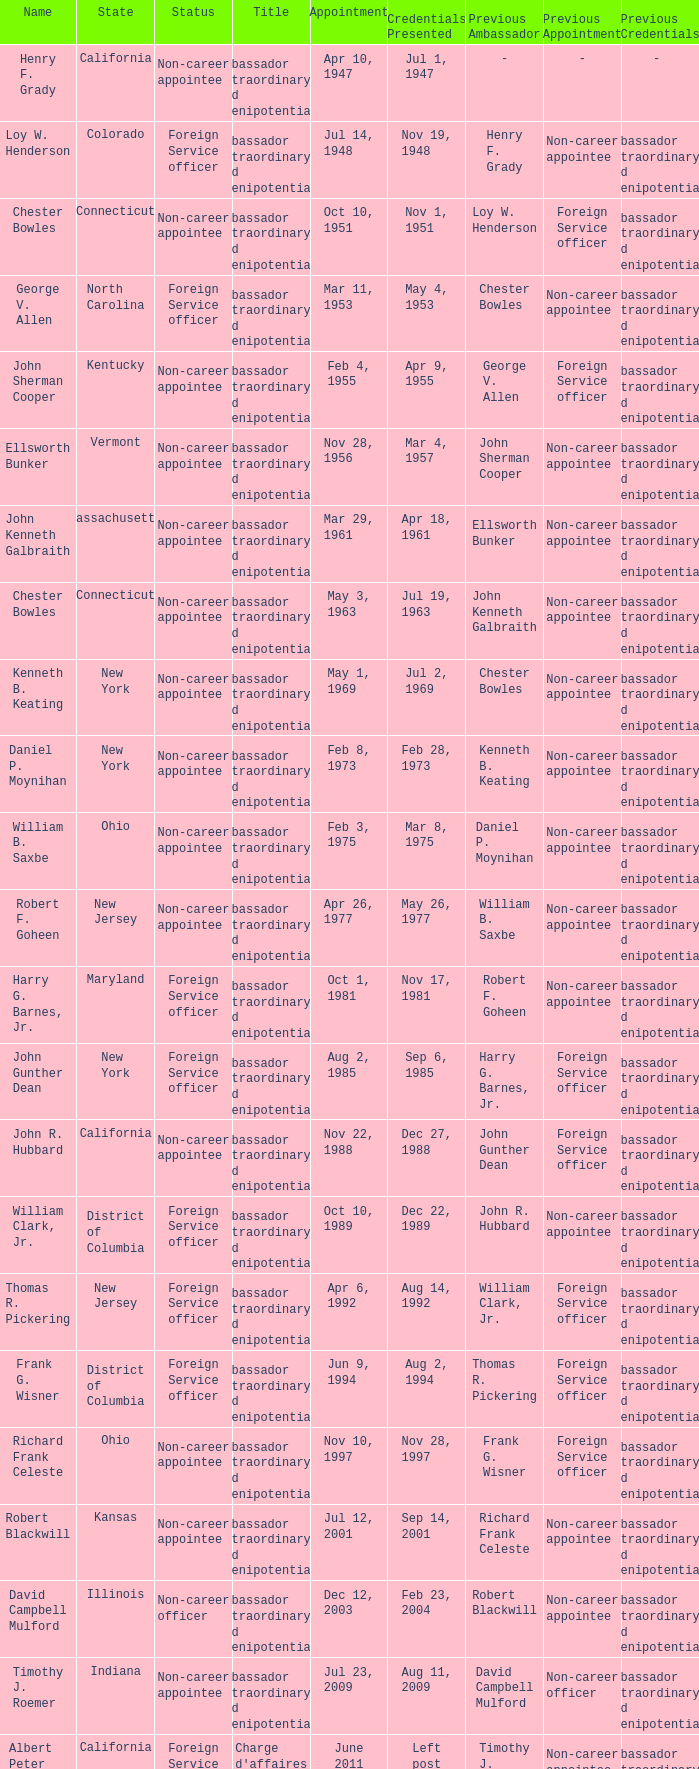When were the credentials presented for new jersey with a status of foreign service officer? Aug 14, 1992. 